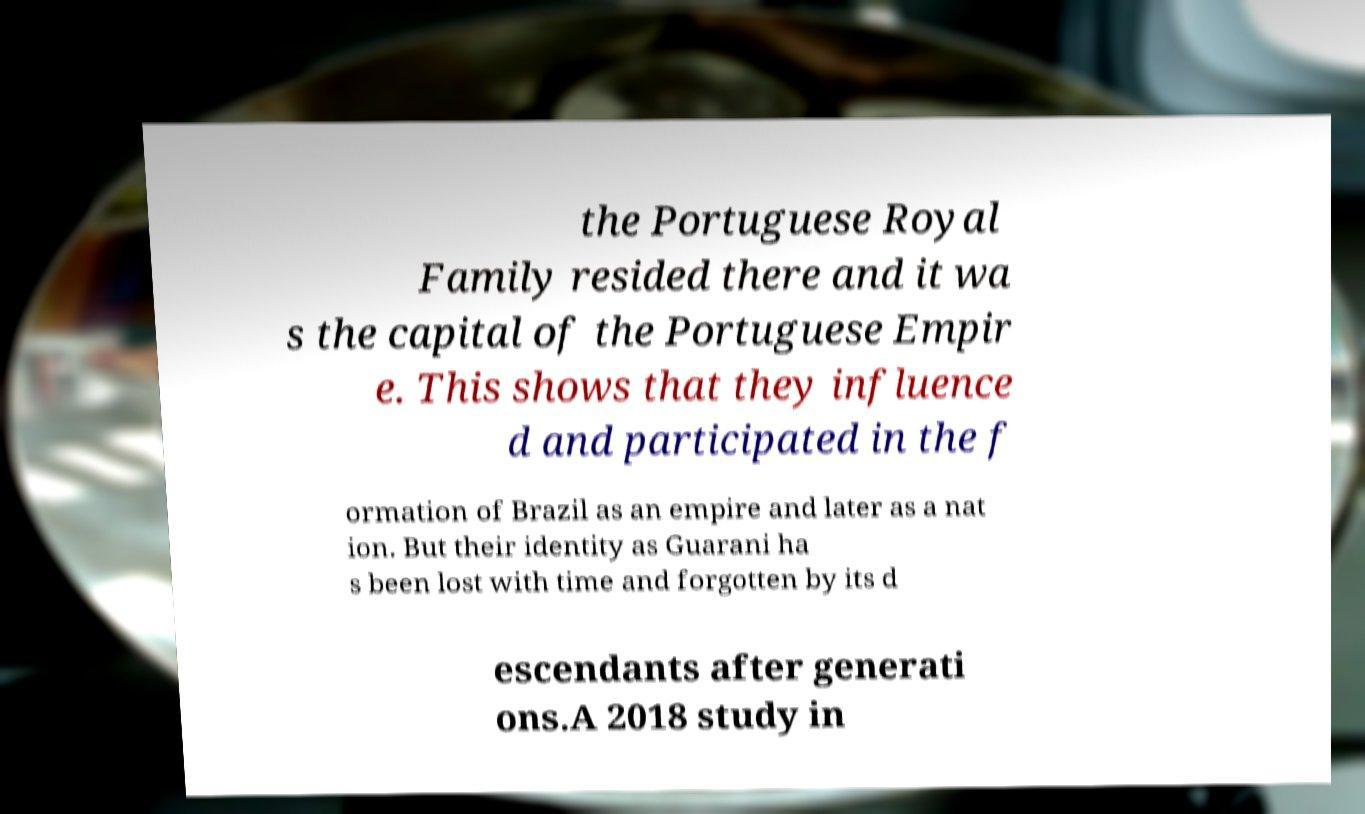What messages or text are displayed in this image? I need them in a readable, typed format. the Portuguese Royal Family resided there and it wa s the capital of the Portuguese Empir e. This shows that they influence d and participated in the f ormation of Brazil as an empire and later as a nat ion. But their identity as Guarani ha s been lost with time and forgotten by its d escendants after generati ons.A 2018 study in 